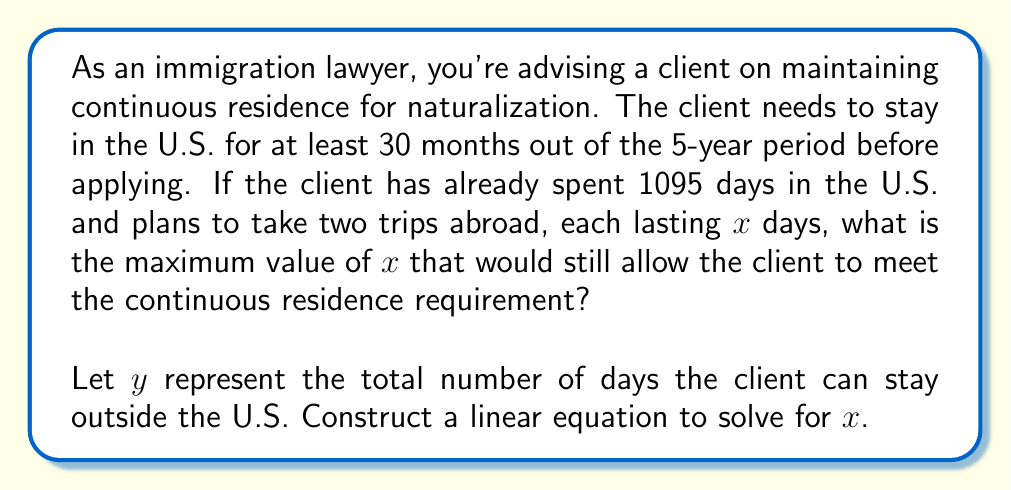Show me your answer to this math problem. To solve this problem, we need to follow these steps:

1. Convert the given information into days:
   - 5 years = 1825 days
   - 30 months ≈ 913 days (minimum required in the U.S.)
   - The client has already spent 1095 days in the U.S.

2. Set up the linear equation:
   The total days outside the U.S. ($y$) plus the days already spent in the U.S. (1095) should equal the total days in 5 years (1825):
   
   $$y + 1095 = 1825$$

3. Solve for $y$:
   $$y = 1825 - 1095 = 730$$

   This means the client can spend a total of 730 days outside the U.S.

4. Since the client plans to take two trips, each lasting $x$ days, we can set up another equation:
   
   $$2x = 730$$

5. Solve for $x$:
   $$x = 730 \div 2 = 365$$

Therefore, the maximum number of days for each trip ($x$) is 365 days.
Answer: The maximum value of $x$ is 365 days. 